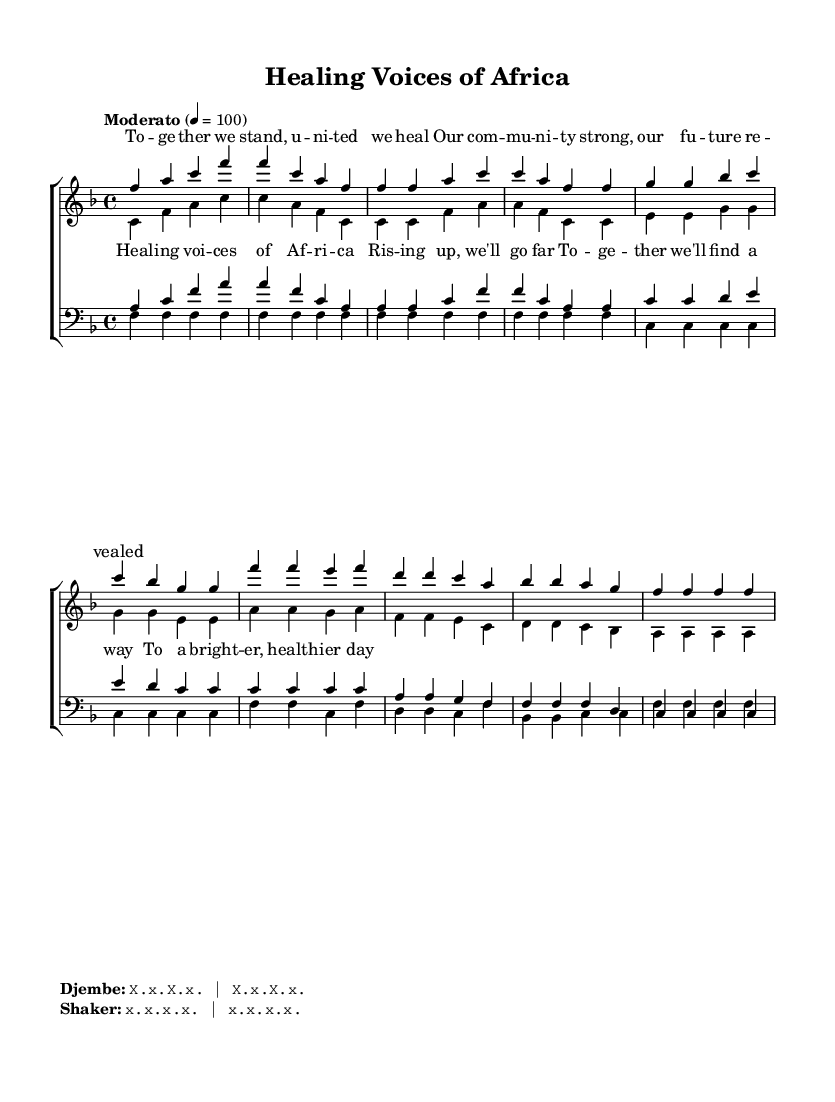What is the key signature of this music? The key signature is F major, indicated by a single flat (B flat) at the beginning of the staff.
Answer: F major What is the time signature of this piece? The time signature is 4/4, which means there are four beats per measure and a quarter note gets one beat. This is found at the beginning of the staff.
Answer: 4/4 What is the tempo marking for this choir piece? The tempo marking is "Moderato," which suggests a moderate speed for the performance of the music. This is located near the beginning of the score.
Answer: Moderato How many measures are in the soprano voice part? The soprano voice part contains 8 measures, as counted sequentially from the beginning to the end of that section.
Answer: 8 What type of ensemble is represented in this score? The score is for a choir, which is indicated by the presence of multiple parts organized into soprano, alto, tenor, and bass sections.
Answer: Choir What are the lyrics for the chorus of the piece? The lyrics for the chorus are:
"Healing voices of Africa
Rising up, we'll go far
Together we'll find a way
To a brighter, healthier day." This can be found under the choir staff labeled for the soprano and alto voices.
Answer: Healing voices of Africa, Rising up, we'll go far, Together we'll find a way, To a brighter, healthier day What is the primary theme celebrated in this music? The primary theme celebrated in this music is community health and healing, as evident from the lyrics and the title, promoting unity and strength in adversity.
Answer: Community health and healing 